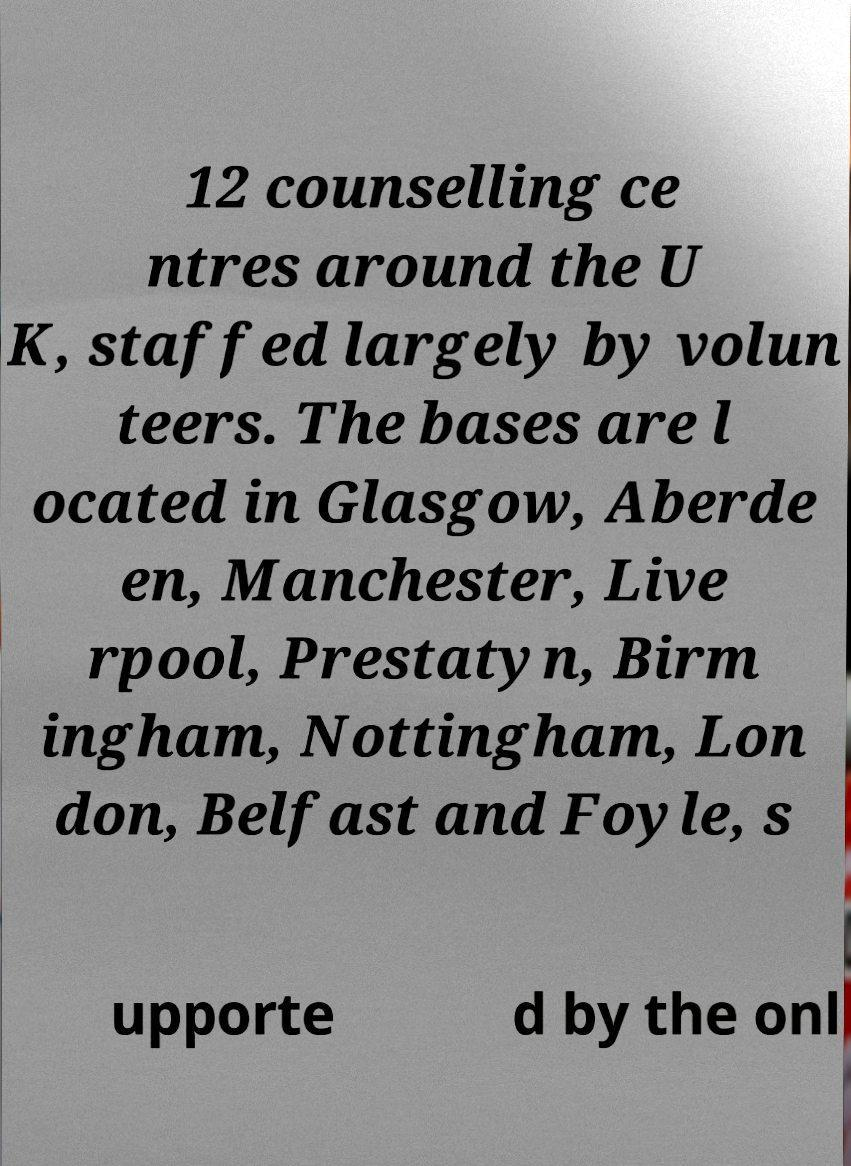Please read and relay the text visible in this image. What does it say? 12 counselling ce ntres around the U K, staffed largely by volun teers. The bases are l ocated in Glasgow, Aberde en, Manchester, Live rpool, Prestatyn, Birm ingham, Nottingham, Lon don, Belfast and Foyle, s upporte d by the onl 